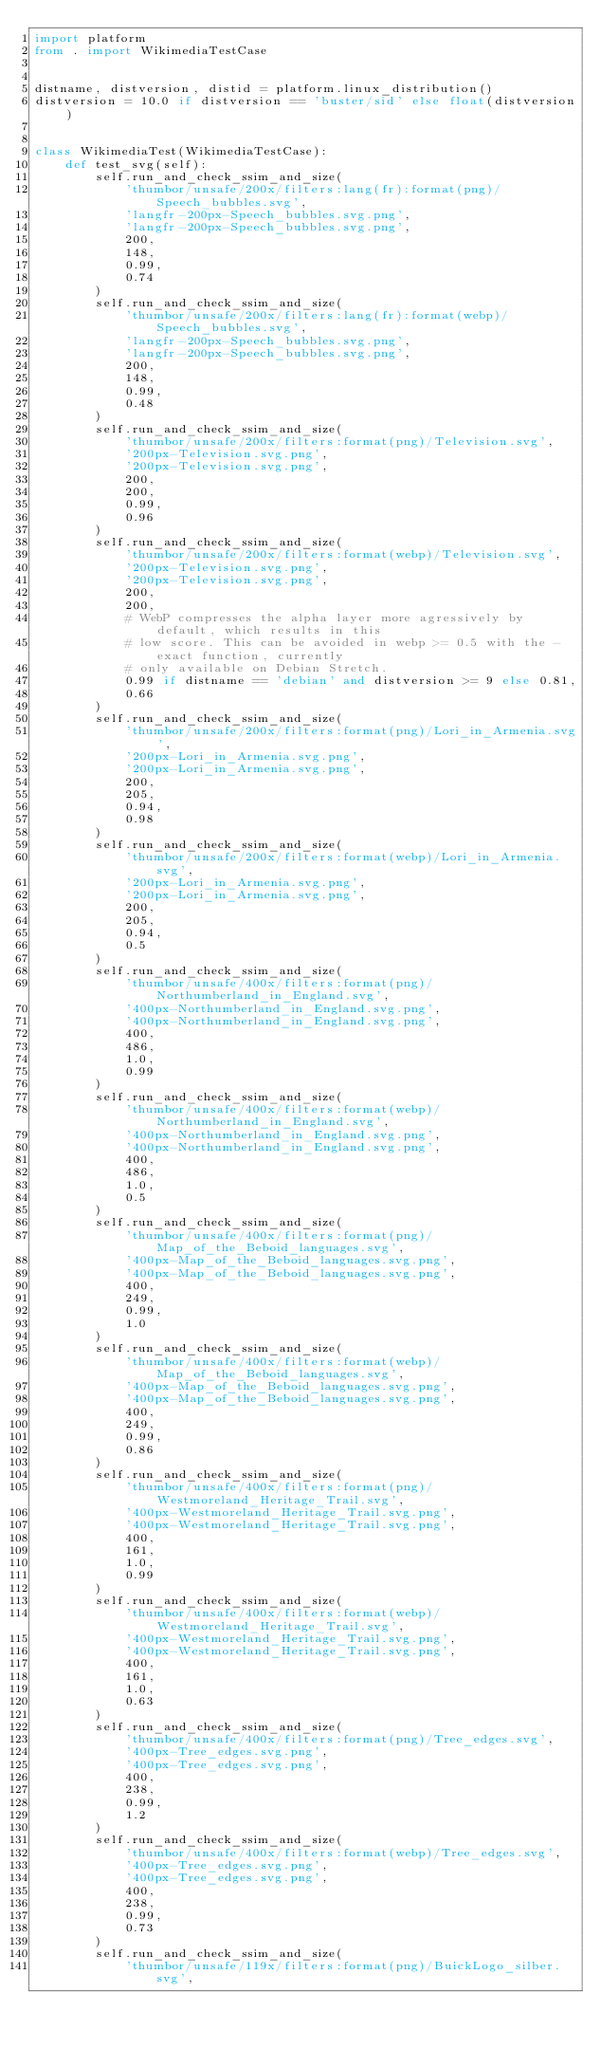Convert code to text. <code><loc_0><loc_0><loc_500><loc_500><_Python_>import platform
from . import WikimediaTestCase


distname, distversion, distid = platform.linux_distribution()
distversion = 10.0 if distversion == 'buster/sid' else float(distversion)


class WikimediaTest(WikimediaTestCase):
    def test_svg(self):
        self.run_and_check_ssim_and_size(
            'thumbor/unsafe/200x/filters:lang(fr):format(png)/Speech_bubbles.svg',
            'langfr-200px-Speech_bubbles.svg.png',
            'langfr-200px-Speech_bubbles.svg.png',
            200,
            148,
            0.99,
            0.74
        )
        self.run_and_check_ssim_and_size(
            'thumbor/unsafe/200x/filters:lang(fr):format(webp)/Speech_bubbles.svg',
            'langfr-200px-Speech_bubbles.svg.png',
            'langfr-200px-Speech_bubbles.svg.png',
            200,
            148,
            0.99,
            0.48
        )
        self.run_and_check_ssim_and_size(
            'thumbor/unsafe/200x/filters:format(png)/Television.svg',
            '200px-Television.svg.png',
            '200px-Television.svg.png',
            200,
            200,
            0.99,
            0.96
        )
        self.run_and_check_ssim_and_size(
            'thumbor/unsafe/200x/filters:format(webp)/Television.svg',
            '200px-Television.svg.png',
            '200px-Television.svg.png',
            200,
            200,
            # WebP compresses the alpha layer more agressively by default, which results in this
            # low score. This can be avoided in webp >= 0.5 with the -exact function, currently
            # only available on Debian Stretch.
            0.99 if distname == 'debian' and distversion >= 9 else 0.81,
            0.66
        )
        self.run_and_check_ssim_and_size(
            'thumbor/unsafe/200x/filters:format(png)/Lori_in_Armenia.svg',
            '200px-Lori_in_Armenia.svg.png',
            '200px-Lori_in_Armenia.svg.png',
            200,
            205,
            0.94,
            0.98
        )
        self.run_and_check_ssim_and_size(
            'thumbor/unsafe/200x/filters:format(webp)/Lori_in_Armenia.svg',
            '200px-Lori_in_Armenia.svg.png',
            '200px-Lori_in_Armenia.svg.png',
            200,
            205,
            0.94,
            0.5
        )
        self.run_and_check_ssim_and_size(
            'thumbor/unsafe/400x/filters:format(png)/Northumberland_in_England.svg',
            '400px-Northumberland_in_England.svg.png',
            '400px-Northumberland_in_England.svg.png',
            400,
            486,
            1.0,
            0.99
        )
        self.run_and_check_ssim_and_size(
            'thumbor/unsafe/400x/filters:format(webp)/Northumberland_in_England.svg',
            '400px-Northumberland_in_England.svg.png',
            '400px-Northumberland_in_England.svg.png',
            400,
            486,
            1.0,
            0.5
        )
        self.run_and_check_ssim_and_size(
            'thumbor/unsafe/400x/filters:format(png)/Map_of_the_Beboid_languages.svg',
            '400px-Map_of_the_Beboid_languages.svg.png',
            '400px-Map_of_the_Beboid_languages.svg.png',
            400,
            249,
            0.99,
            1.0
        )
        self.run_and_check_ssim_and_size(
            'thumbor/unsafe/400x/filters:format(webp)/Map_of_the_Beboid_languages.svg',
            '400px-Map_of_the_Beboid_languages.svg.png',
            '400px-Map_of_the_Beboid_languages.svg.png',
            400,
            249,
            0.99,
            0.86
        )
        self.run_and_check_ssim_and_size(
            'thumbor/unsafe/400x/filters:format(png)/Westmoreland_Heritage_Trail.svg',
            '400px-Westmoreland_Heritage_Trail.svg.png',
            '400px-Westmoreland_Heritage_Trail.svg.png',
            400,
            161,
            1.0,
            0.99
        )
        self.run_and_check_ssim_and_size(
            'thumbor/unsafe/400x/filters:format(webp)/Westmoreland_Heritage_Trail.svg',
            '400px-Westmoreland_Heritage_Trail.svg.png',
            '400px-Westmoreland_Heritage_Trail.svg.png',
            400,
            161,
            1.0,
            0.63
        )
        self.run_and_check_ssim_and_size(
            'thumbor/unsafe/400x/filters:format(png)/Tree_edges.svg',
            '400px-Tree_edges.svg.png',
            '400px-Tree_edges.svg.png',
            400,
            238,
            0.99,
            1.2
        )
        self.run_and_check_ssim_and_size(
            'thumbor/unsafe/400x/filters:format(webp)/Tree_edges.svg',
            '400px-Tree_edges.svg.png',
            '400px-Tree_edges.svg.png',
            400,
            238,
            0.99,
            0.73
        )
        self.run_and_check_ssim_and_size(
            'thumbor/unsafe/119x/filters:format(png)/BuickLogo_silber.svg',</code> 